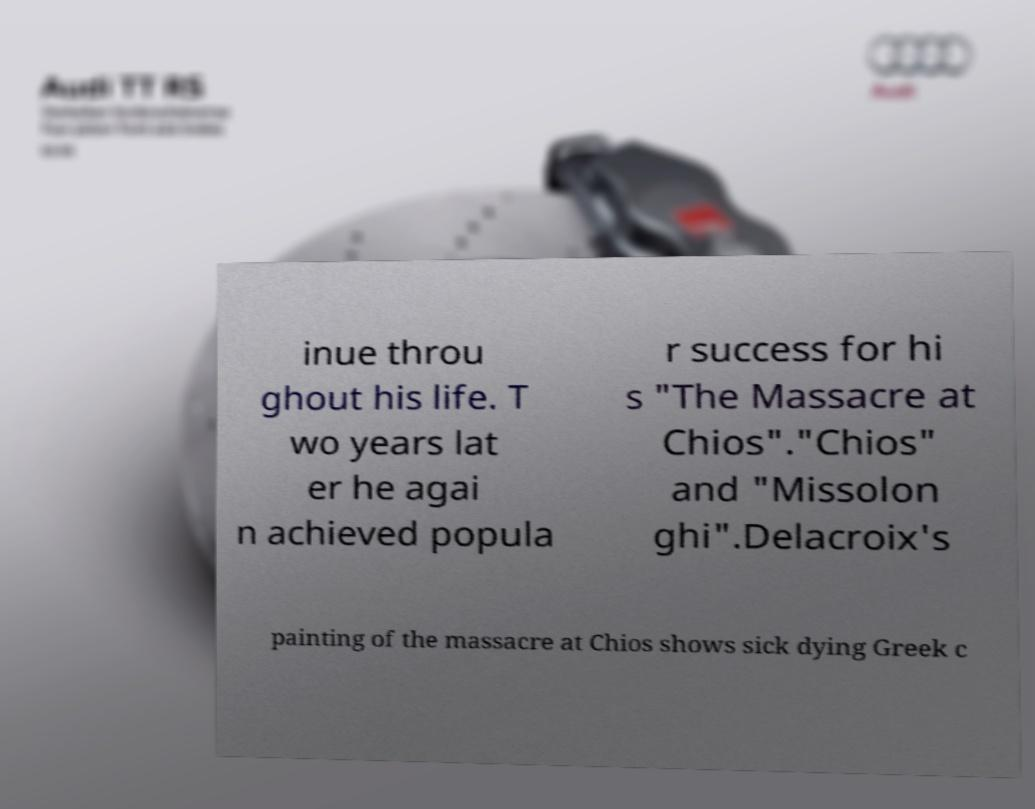For documentation purposes, I need the text within this image transcribed. Could you provide that? inue throu ghout his life. T wo years lat er he agai n achieved popula r success for hi s "The Massacre at Chios"."Chios" and "Missolon ghi".Delacroix's painting of the massacre at Chios shows sick dying Greek c 